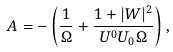Convert formula to latex. <formula><loc_0><loc_0><loc_500><loc_500>A = - \left ( \frac { 1 } { \Omega } + \frac { 1 + | W | ^ { 2 } } { U ^ { 0 } U _ { 0 } \Omega } \right ) ,</formula> 